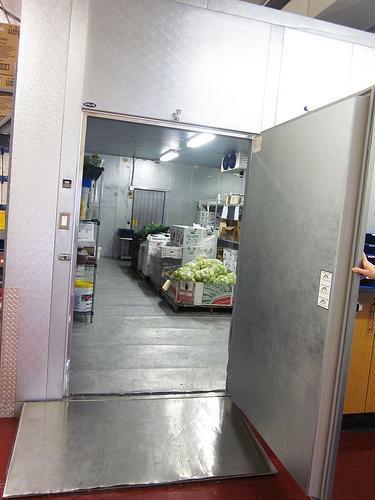How many people in the room?
Give a very brief answer. 0. 